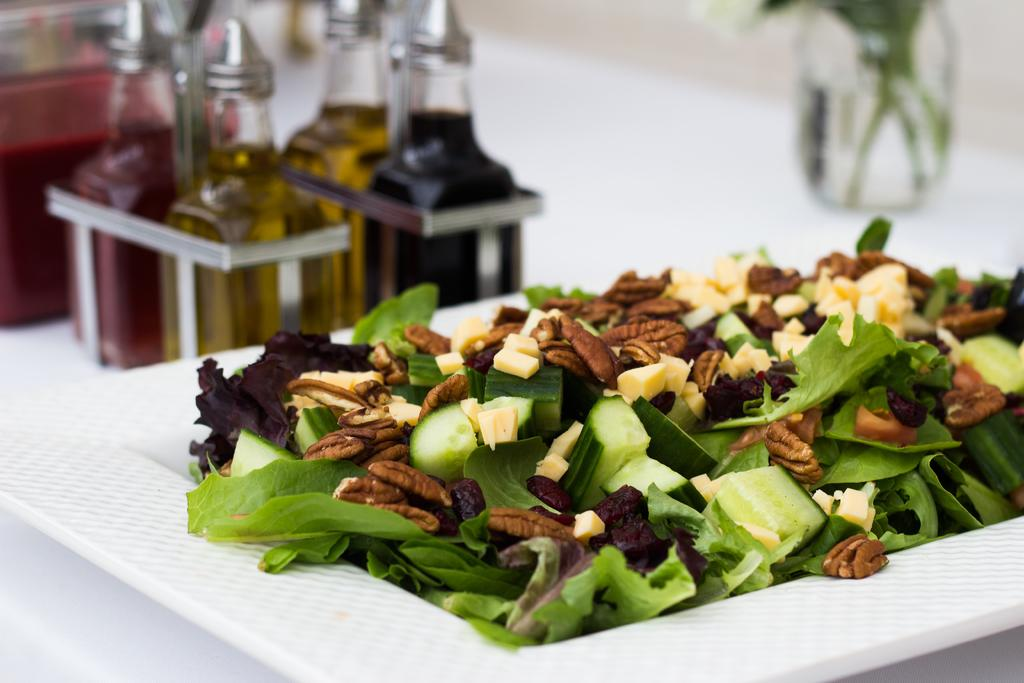What type of plant material is present in the image? There are leaves in the image. What type of food items can be seen in the image? There are vegetables and nuts on a plate in the image. What is located in the background of the image? There is a glass bottle and a wall in the background of the image. How would you describe the background of the image? The background is blurry. What time of day is depicted in the image? The time of day is not mentioned or depicted in the image. What type of test can be seen being conducted in the image? There is no test or testing activity present in the image. 